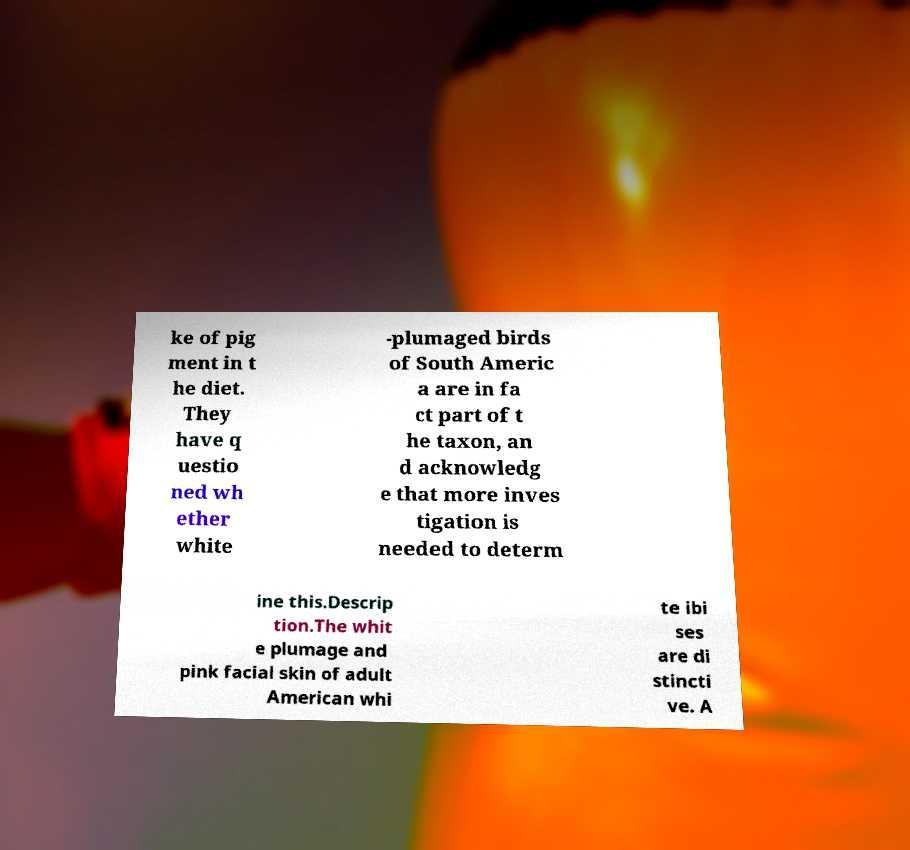I need the written content from this picture converted into text. Can you do that? ke of pig ment in t he diet. They have q uestio ned wh ether white -plumaged birds of South Americ a are in fa ct part of t he taxon, an d acknowledg e that more inves tigation is needed to determ ine this.Descrip tion.The whit e plumage and pink facial skin of adult American whi te ibi ses are di stincti ve. A 